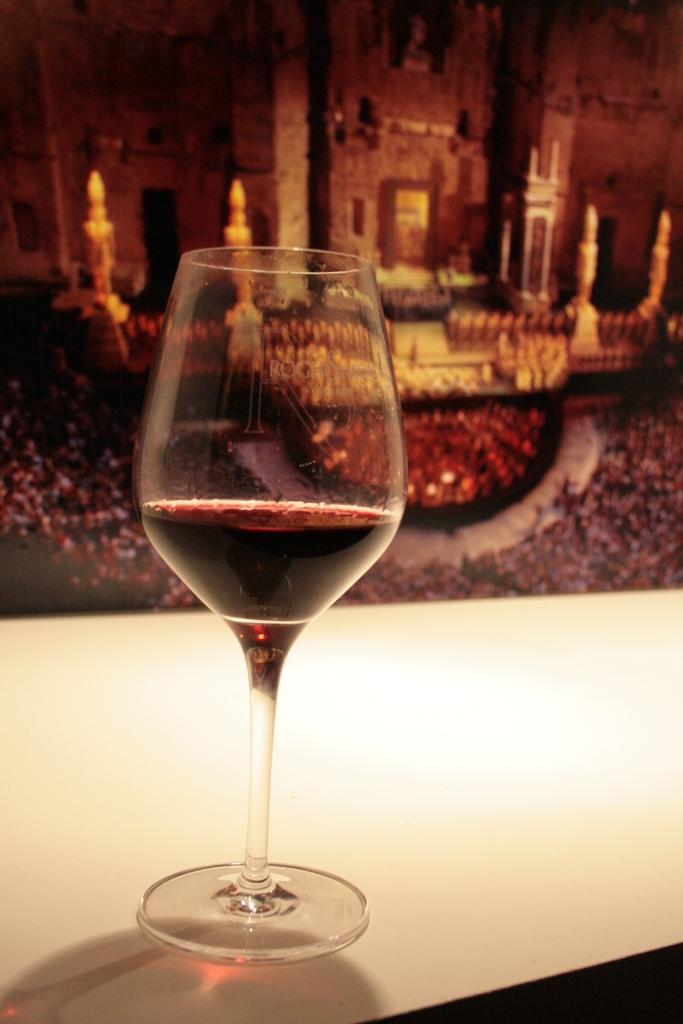What object is on the table in the image? There is a glass on the table in the image. What is inside the glass? There is liquid in the glass. What can be seen in the distance behind the table? There is a building visible in the background. What type of friction can be observed between the glass and the table in the image? There is no observable friction between the glass and the table in the image. Can you see a cow grazing in the background of the image? There is no cow present in the image; only a building is visible in the background. 